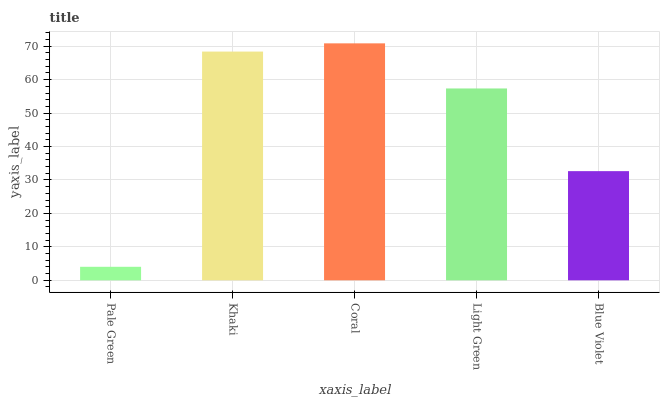Is Pale Green the minimum?
Answer yes or no. Yes. Is Coral the maximum?
Answer yes or no. Yes. Is Khaki the minimum?
Answer yes or no. No. Is Khaki the maximum?
Answer yes or no. No. Is Khaki greater than Pale Green?
Answer yes or no. Yes. Is Pale Green less than Khaki?
Answer yes or no. Yes. Is Pale Green greater than Khaki?
Answer yes or no. No. Is Khaki less than Pale Green?
Answer yes or no. No. Is Light Green the high median?
Answer yes or no. Yes. Is Light Green the low median?
Answer yes or no. Yes. Is Blue Violet the high median?
Answer yes or no. No. Is Pale Green the low median?
Answer yes or no. No. 